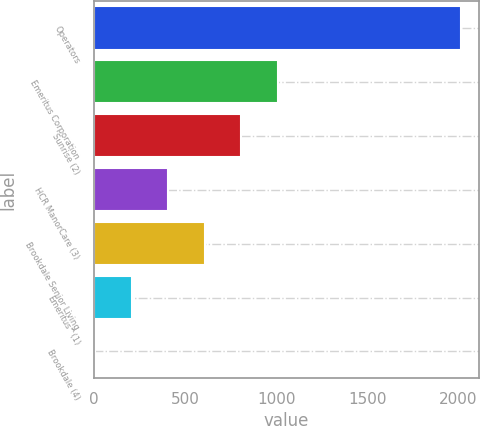<chart> <loc_0><loc_0><loc_500><loc_500><bar_chart><fcel>Operators<fcel>Emeritus Corporation<fcel>Sunrise (2)<fcel>HCR ManorCare (3)<fcel>Brookdale Senior Living<fcel>Emeritus^(1)<fcel>Brookdale (4)<nl><fcel>2012<fcel>1008.5<fcel>807.8<fcel>406.4<fcel>607.1<fcel>205.7<fcel>5<nl></chart> 